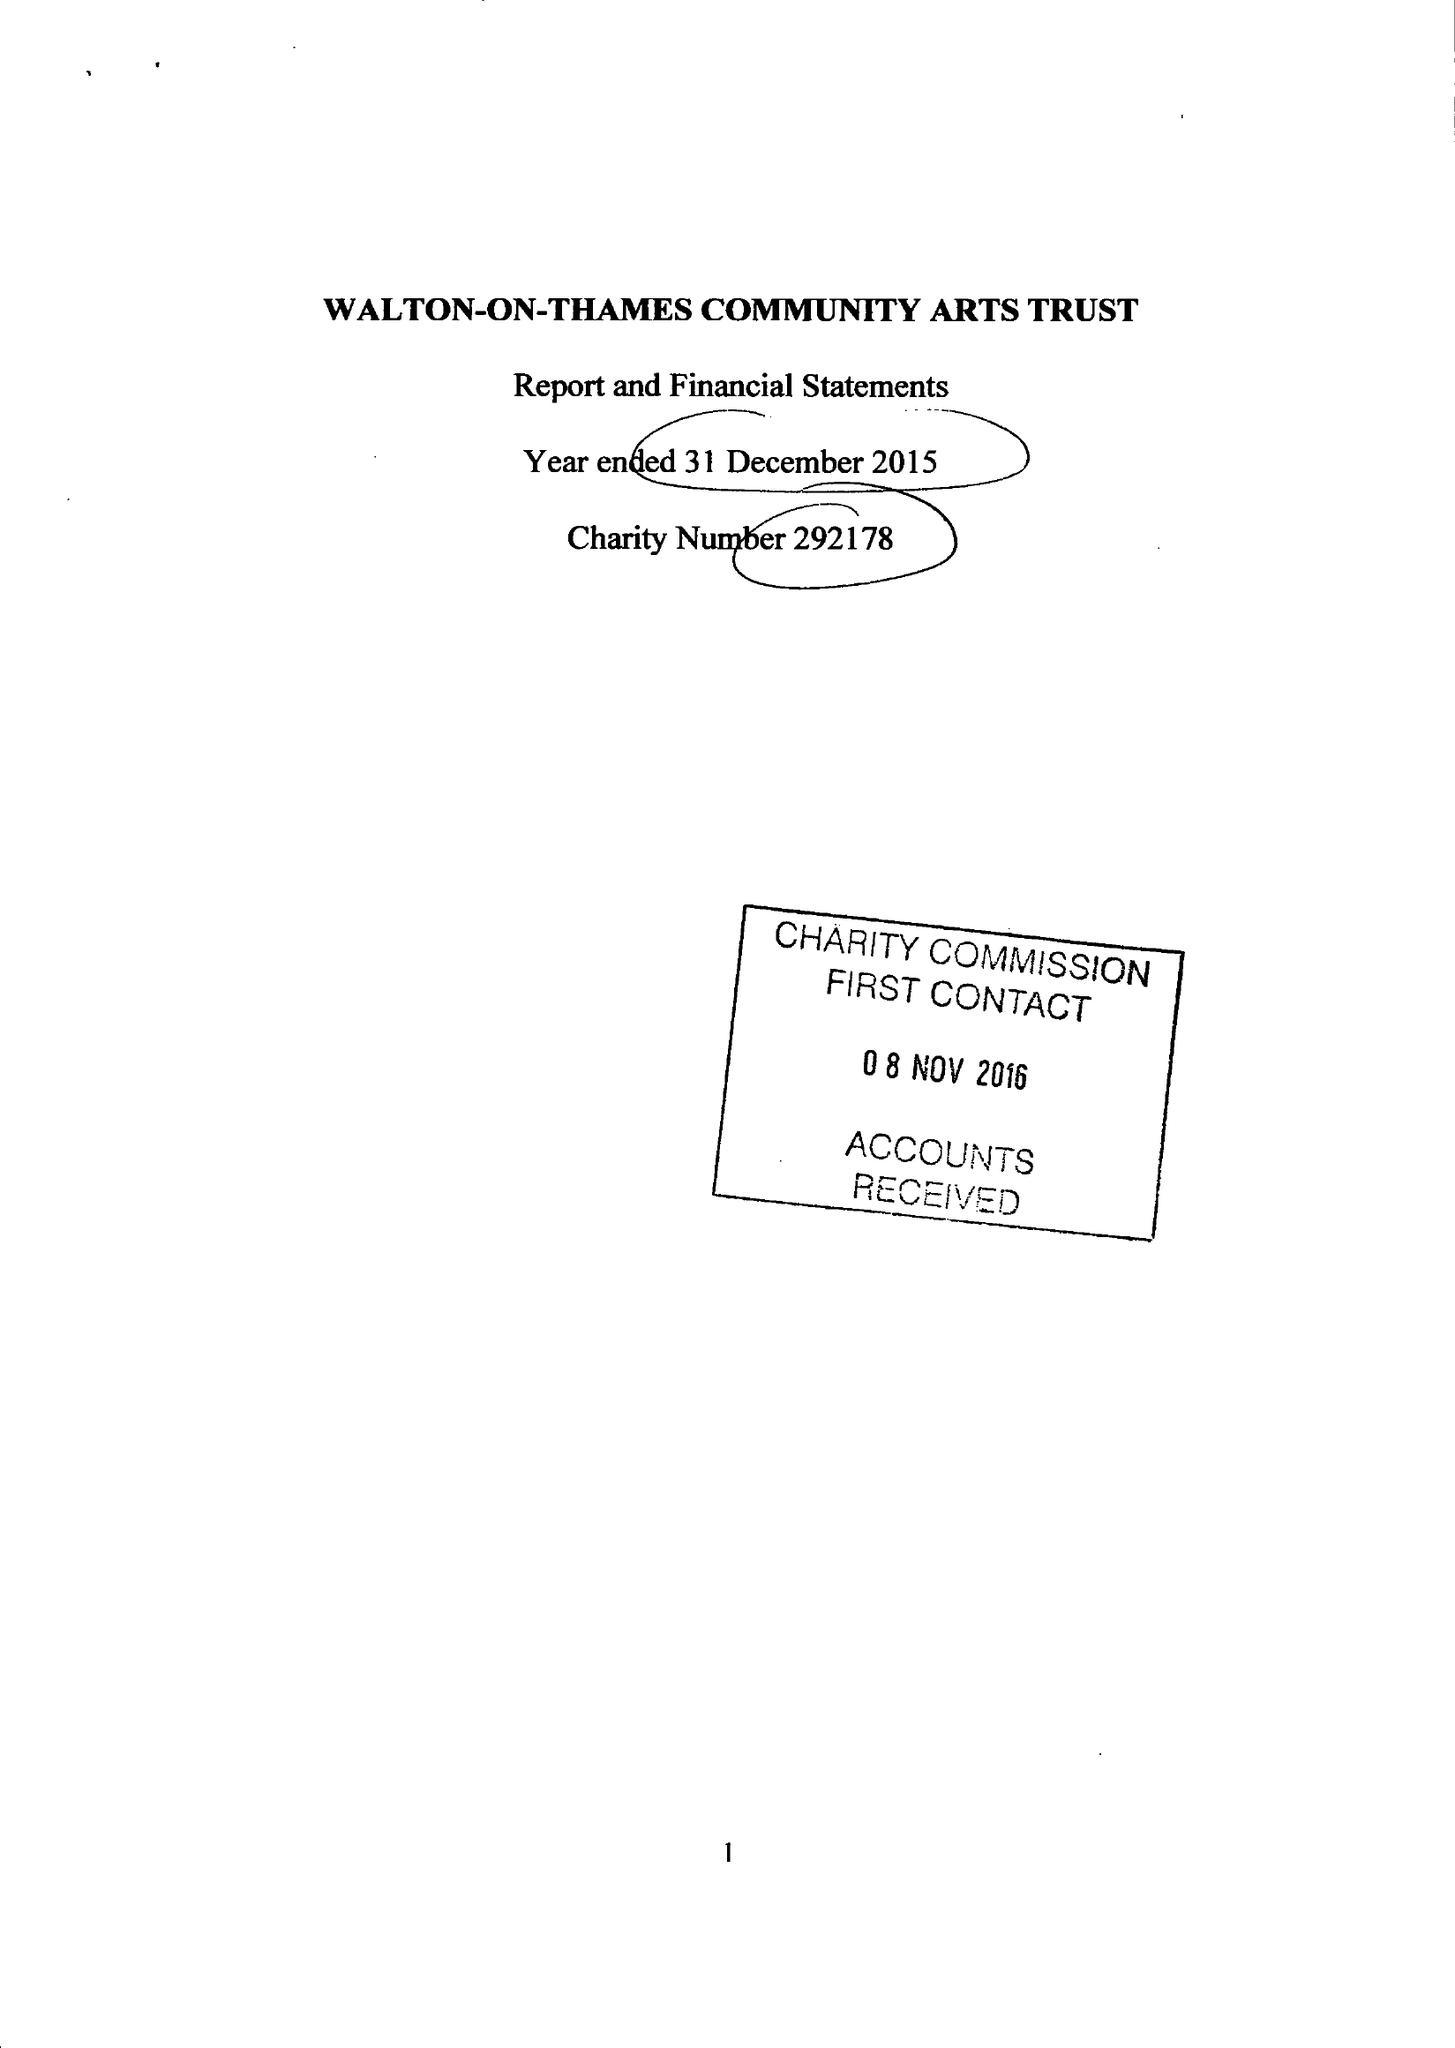What is the value for the income_annually_in_british_pounds?
Answer the question using a single word or phrase. 33114.00 